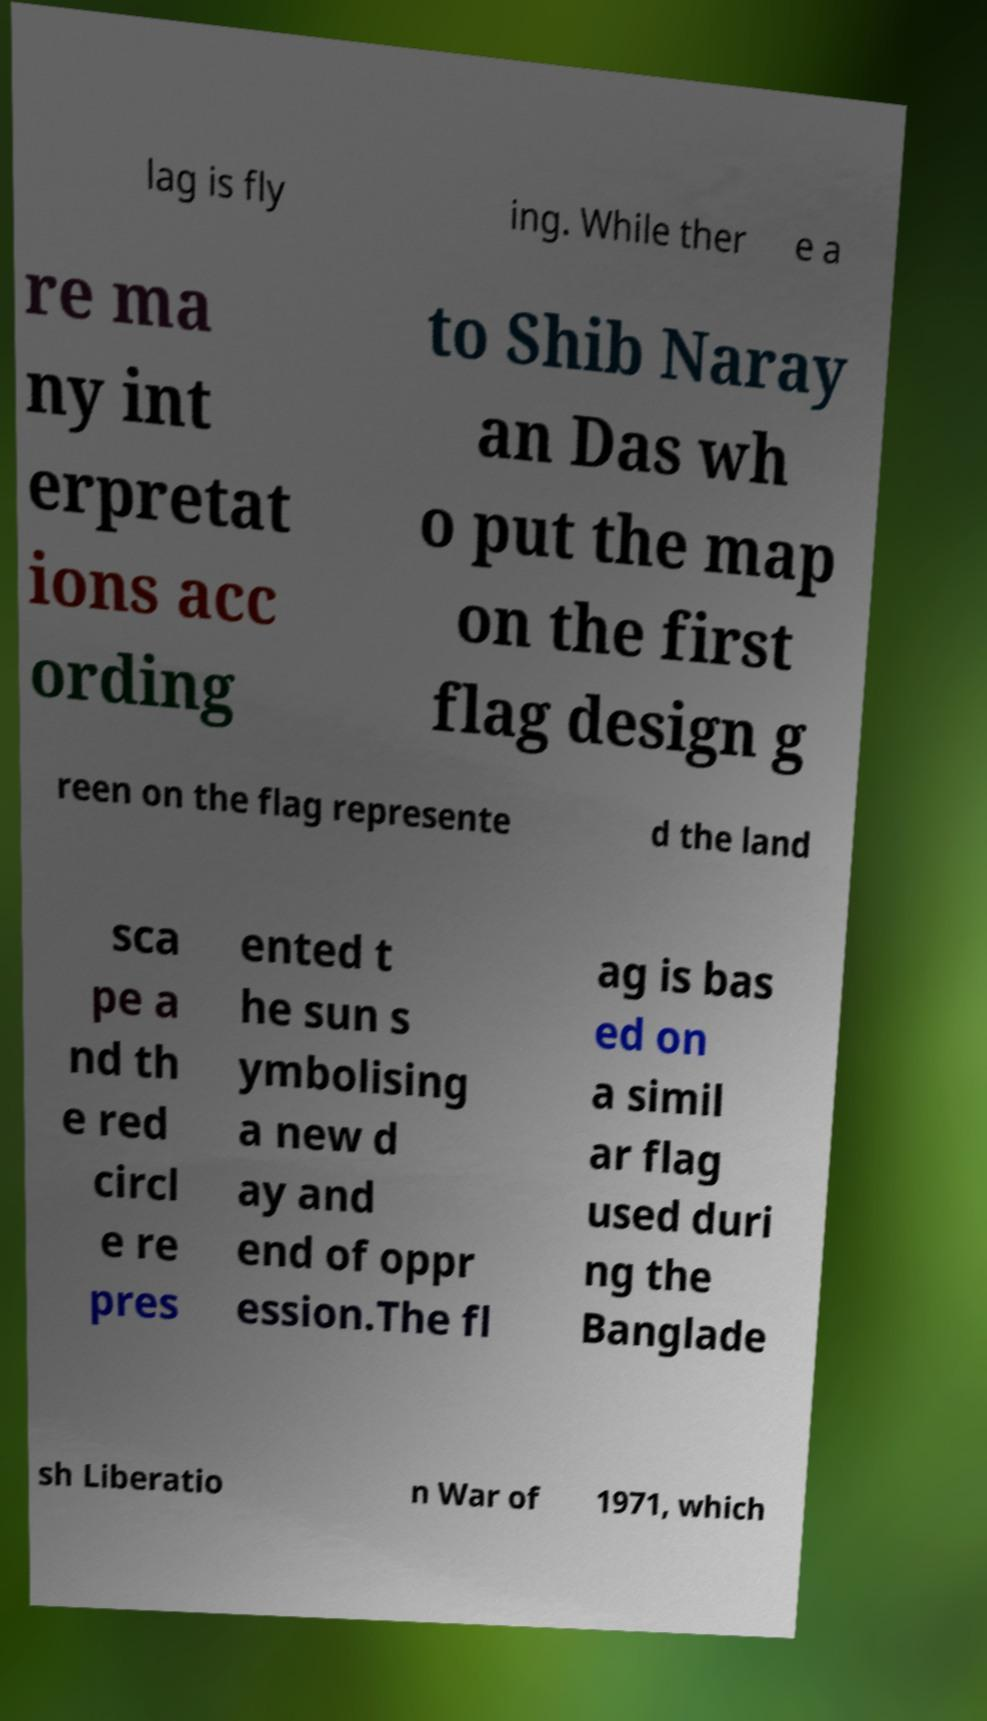What messages or text are displayed in this image? I need them in a readable, typed format. lag is fly ing. While ther e a re ma ny int erpretat ions acc ording to Shib Naray an Das wh o put the map on the first flag design g reen on the flag represente d the land sca pe a nd th e red circl e re pres ented t he sun s ymbolising a new d ay and end of oppr ession.The fl ag is bas ed on a simil ar flag used duri ng the Banglade sh Liberatio n War of 1971, which 